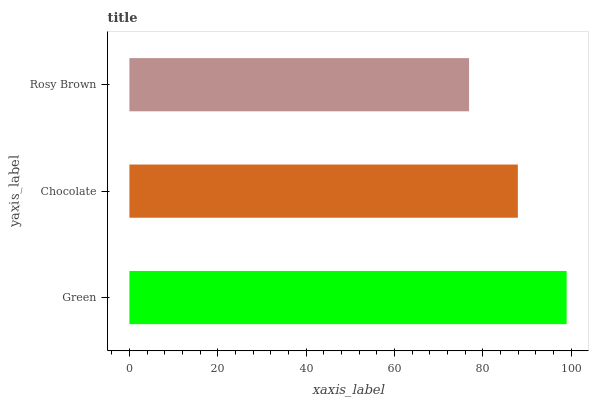Is Rosy Brown the minimum?
Answer yes or no. Yes. Is Green the maximum?
Answer yes or no. Yes. Is Chocolate the minimum?
Answer yes or no. No. Is Chocolate the maximum?
Answer yes or no. No. Is Green greater than Chocolate?
Answer yes or no. Yes. Is Chocolate less than Green?
Answer yes or no. Yes. Is Chocolate greater than Green?
Answer yes or no. No. Is Green less than Chocolate?
Answer yes or no. No. Is Chocolate the high median?
Answer yes or no. Yes. Is Chocolate the low median?
Answer yes or no. Yes. Is Green the high median?
Answer yes or no. No. Is Rosy Brown the low median?
Answer yes or no. No. 